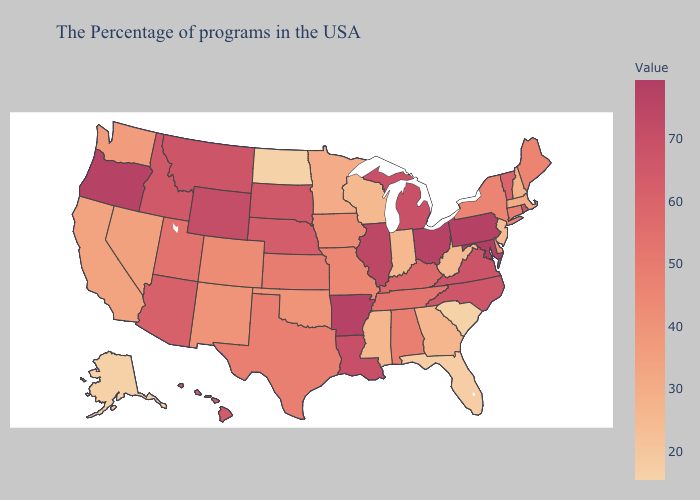Does Georgia have the highest value in the South?
Answer briefly. No. Does Vermont have the lowest value in the USA?
Be succinct. No. Which states have the lowest value in the Northeast?
Be succinct. New Jersey. Which states have the lowest value in the USA?
Answer briefly. North Dakota. Which states hav the highest value in the South?
Give a very brief answer. Maryland. Among the states that border New Jersey , does New York have the highest value?
Keep it brief. No. Which states have the lowest value in the USA?
Quick response, please. North Dakota. 